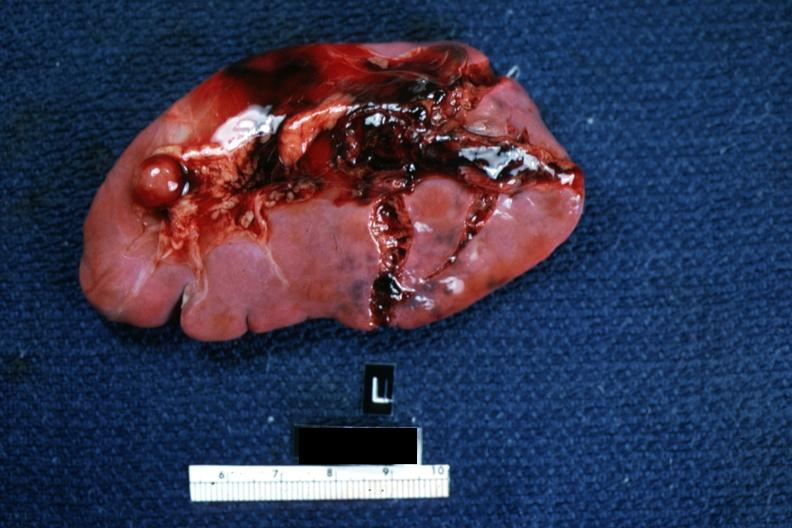s malformed base present?
Answer the question using a single word or phrase. No 